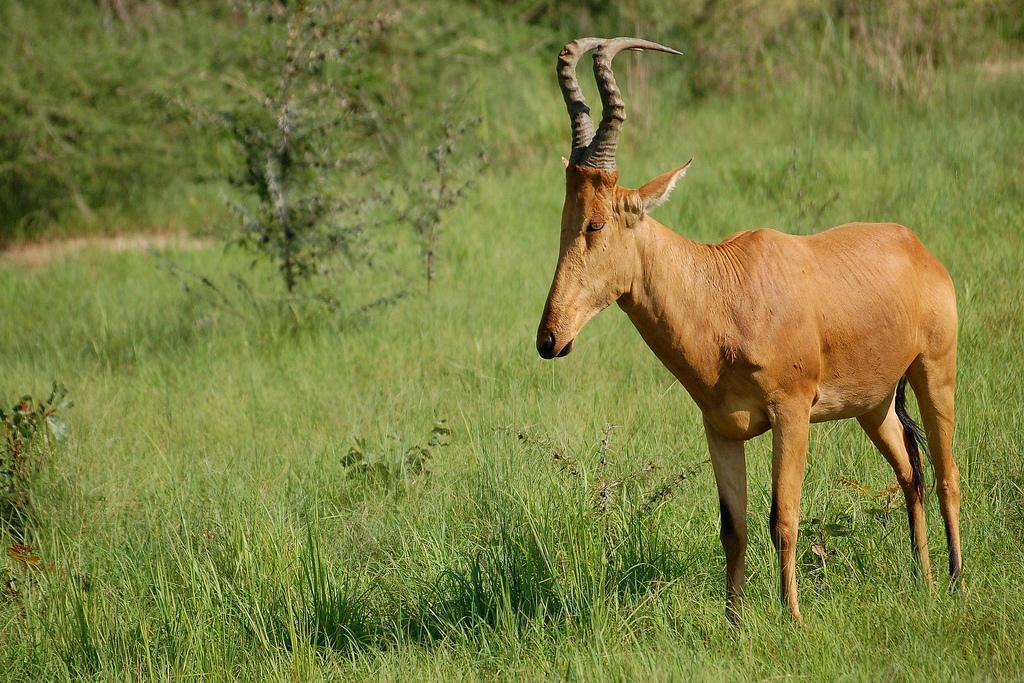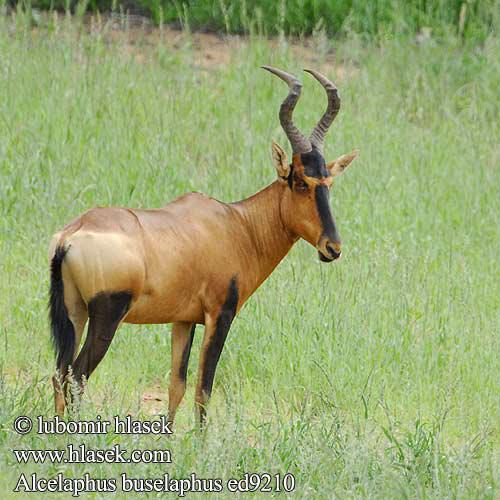The first image is the image on the left, the second image is the image on the right. Examine the images to the left and right. Is the description "At least one image includes a young animal and an adult with horns." accurate? Answer yes or no. No. 